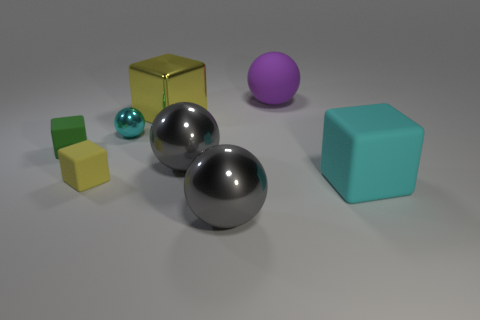Add 1 large blue rubber cylinders. How many objects exist? 9 Subtract 0 gray cylinders. How many objects are left? 8 Subtract all matte spheres. Subtract all big yellow blocks. How many objects are left? 6 Add 4 cyan matte cubes. How many cyan matte cubes are left? 5 Add 2 purple cylinders. How many purple cylinders exist? 2 